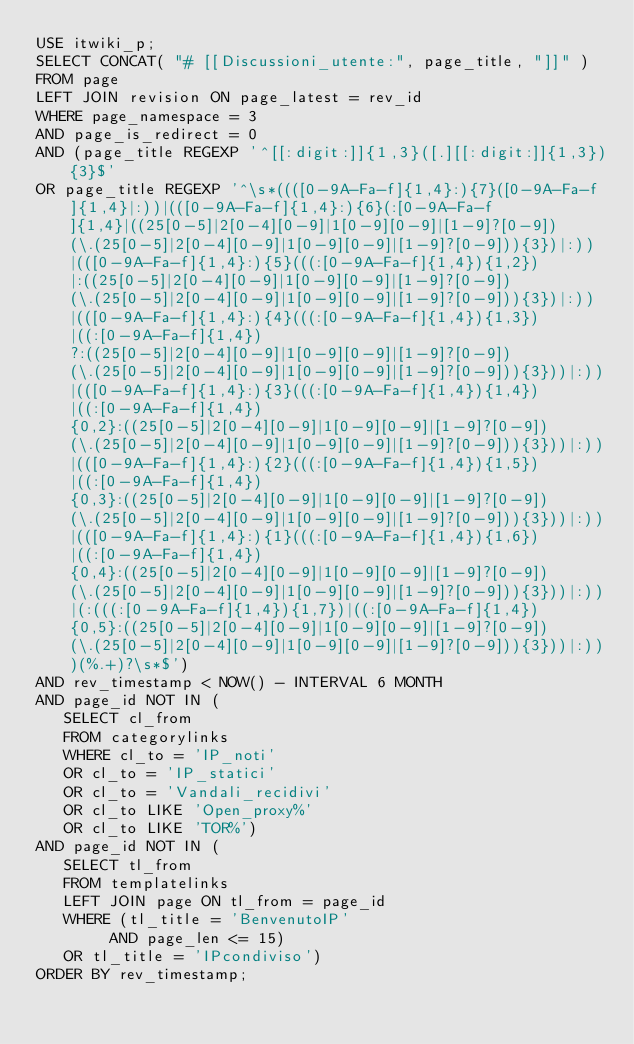Convert code to text. <code><loc_0><loc_0><loc_500><loc_500><_SQL_>USE itwiki_p;
SELECT CONCAT( "# [[Discussioni_utente:", page_title, "]]" )
FROM page
LEFT JOIN revision ON page_latest = rev_id
WHERE page_namespace = 3
AND page_is_redirect = 0
AND (page_title REGEXP '^[[:digit:]]{1,3}([.][[:digit:]]{1,3}){3}$'
OR page_title REGEXP '^\s*((([0-9A-Fa-f]{1,4}:){7}([0-9A-Fa-f]{1,4}|:))|(([0-9A-Fa-f]{1,4}:){6}(:[0-9A-Fa-f]{1,4}|((25[0-5]|2[0-4][0-9]|1[0-9][0-9]|[1-9]?[0-9])(\.(25[0-5]|2[0-4][0-9]|1[0-9][0-9]|[1-9]?[0-9])){3})|:))|(([0-9A-Fa-f]{1,4}:){5}(((:[0-9A-Fa-f]{1,4}){1,2})|:((25[0-5]|2[0-4][0-9]|1[0-9][0-9]|[1-9]?[0-9])(\.(25[0-5]|2[0-4][0-9]|1[0-9][0-9]|[1-9]?[0-9])){3})|:))|(([0-9A-Fa-f]{1,4}:){4}(((:[0-9A-Fa-f]{1,4}){1,3})|((:[0-9A-Fa-f]{1,4})?:((25[0-5]|2[0-4][0-9]|1[0-9][0-9]|[1-9]?[0-9])(\.(25[0-5]|2[0-4][0-9]|1[0-9][0-9]|[1-9]?[0-9])){3}))|:))|(([0-9A-Fa-f]{1,4}:){3}(((:[0-9A-Fa-f]{1,4}){1,4})|((:[0-9A-Fa-f]{1,4}){0,2}:((25[0-5]|2[0-4][0-9]|1[0-9][0-9]|[1-9]?[0-9])(\.(25[0-5]|2[0-4][0-9]|1[0-9][0-9]|[1-9]?[0-9])){3}))|:))|(([0-9A-Fa-f]{1,4}:){2}(((:[0-9A-Fa-f]{1,4}){1,5})|((:[0-9A-Fa-f]{1,4}){0,3}:((25[0-5]|2[0-4][0-9]|1[0-9][0-9]|[1-9]?[0-9])(\.(25[0-5]|2[0-4][0-9]|1[0-9][0-9]|[1-9]?[0-9])){3}))|:))|(([0-9A-Fa-f]{1,4}:){1}(((:[0-9A-Fa-f]{1,4}){1,6})|((:[0-9A-Fa-f]{1,4}){0,4}:((25[0-5]|2[0-4][0-9]|1[0-9][0-9]|[1-9]?[0-9])(\.(25[0-5]|2[0-4][0-9]|1[0-9][0-9]|[1-9]?[0-9])){3}))|:))|(:(((:[0-9A-Fa-f]{1,4}){1,7})|((:[0-9A-Fa-f]{1,4}){0,5}:((25[0-5]|2[0-4][0-9]|1[0-9][0-9]|[1-9]?[0-9])(\.(25[0-5]|2[0-4][0-9]|1[0-9][0-9]|[1-9]?[0-9])){3}))|:)))(%.+)?\s*$')
AND rev_timestamp < NOW() - INTERVAL 6 MONTH
AND page_id NOT IN (
   SELECT cl_from
   FROM categorylinks
   WHERE cl_to = 'IP_noti'
   OR cl_to = 'IP_statici'
   OR cl_to = 'Vandali_recidivi'
   OR cl_to LIKE 'Open_proxy%'
   OR cl_to LIKE 'TOR%')
AND page_id NOT IN (
   SELECT tl_from
   FROM templatelinks
   LEFT JOIN page ON tl_from = page_id
   WHERE (tl_title = 'BenvenutoIP'
		AND page_len <= 15)
   OR tl_title = 'IPcondiviso')
ORDER BY rev_timestamp;
</code> 